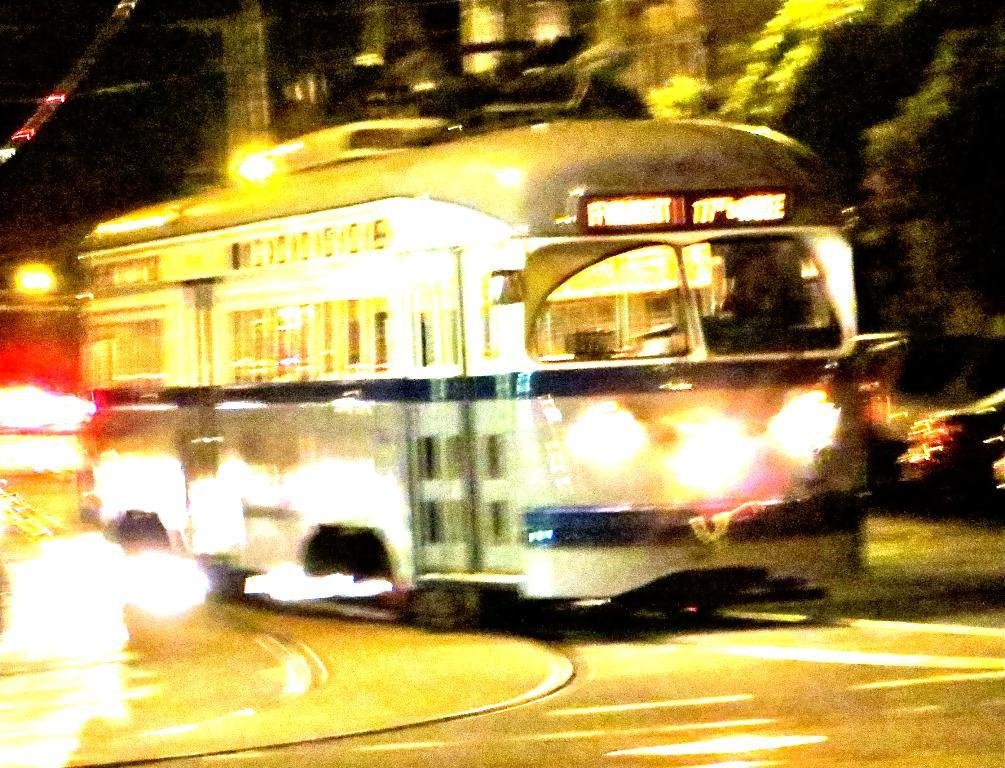What can be seen on the road in the image? There are vehicles on the road in the image. What type of natural elements can be seen in the image? There are trees visible in the image. Can you describe any other objects present in the image? There are other objects present in the image, but their specific details are not mentioned in the provided facts. What type of action is taking place at the airport in the image? There is no airport present in the image, so no action related to an airport can be observed. How many cars are visible in the image? The provided facts do not mention the presence of cars in the image, so we cannot determine the number of cars visible. 